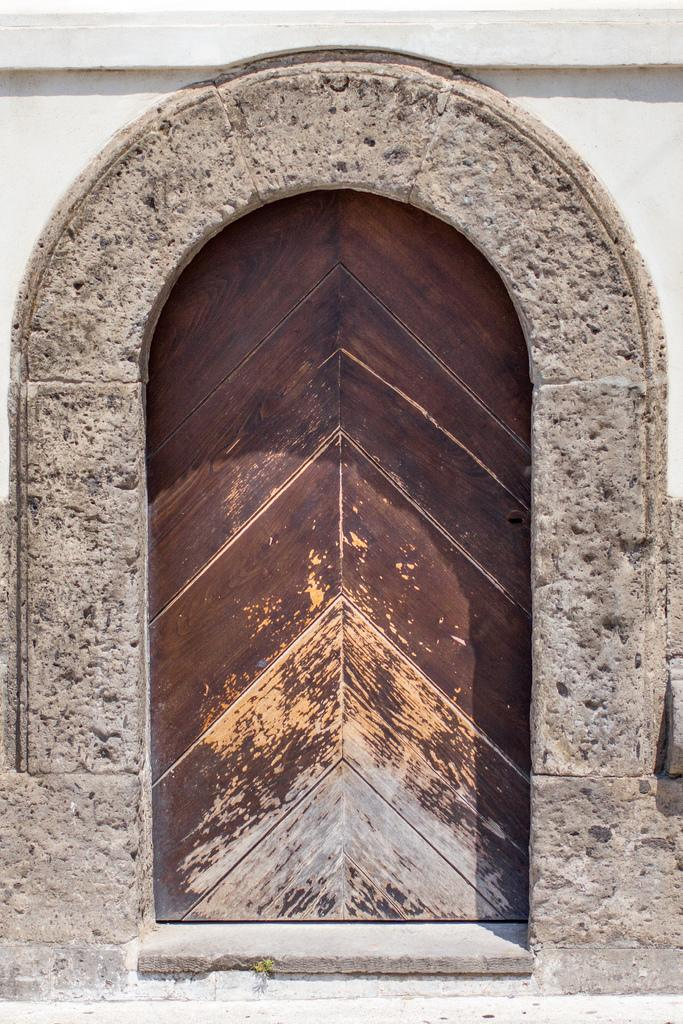What is the color of the building in the image? The building in the image is white. What is the color of the door in the image? The door in the image is brown. What type of shirt is the creator wearing in the image? There is no creator or shirt present in the image; it only features a white building and a brown door. 